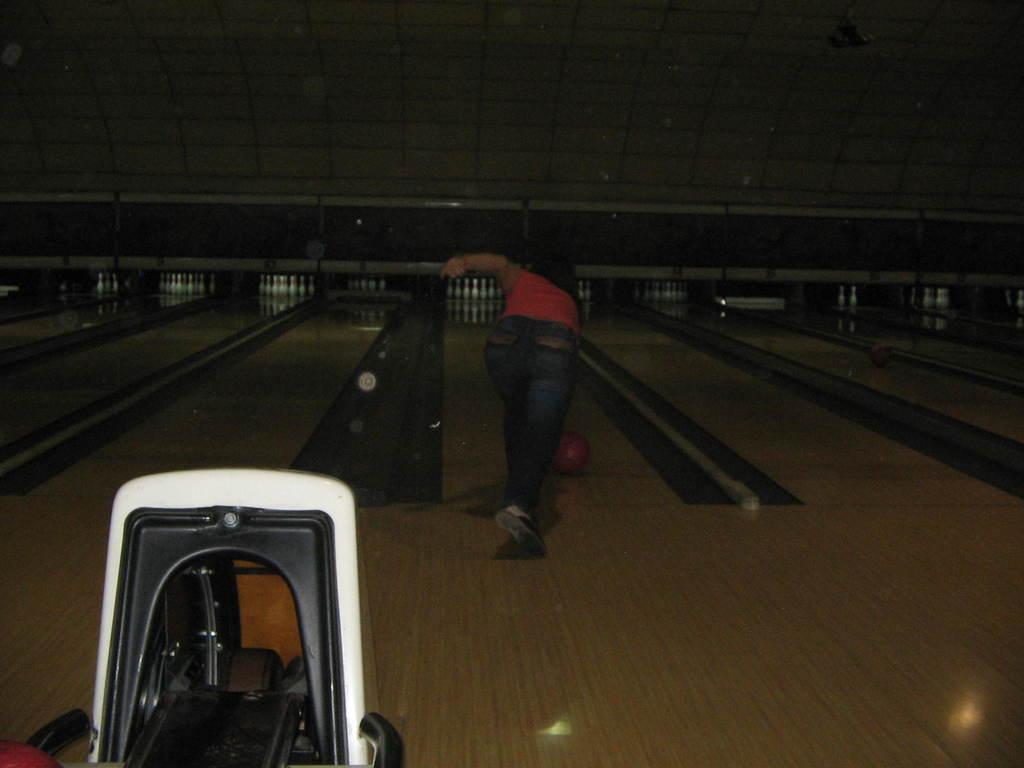How would you summarize this image in a sentence or two? In this picture we can see an object, person standing, ball on a platform and in the background we can see nine pin bowling sets and the wall. 